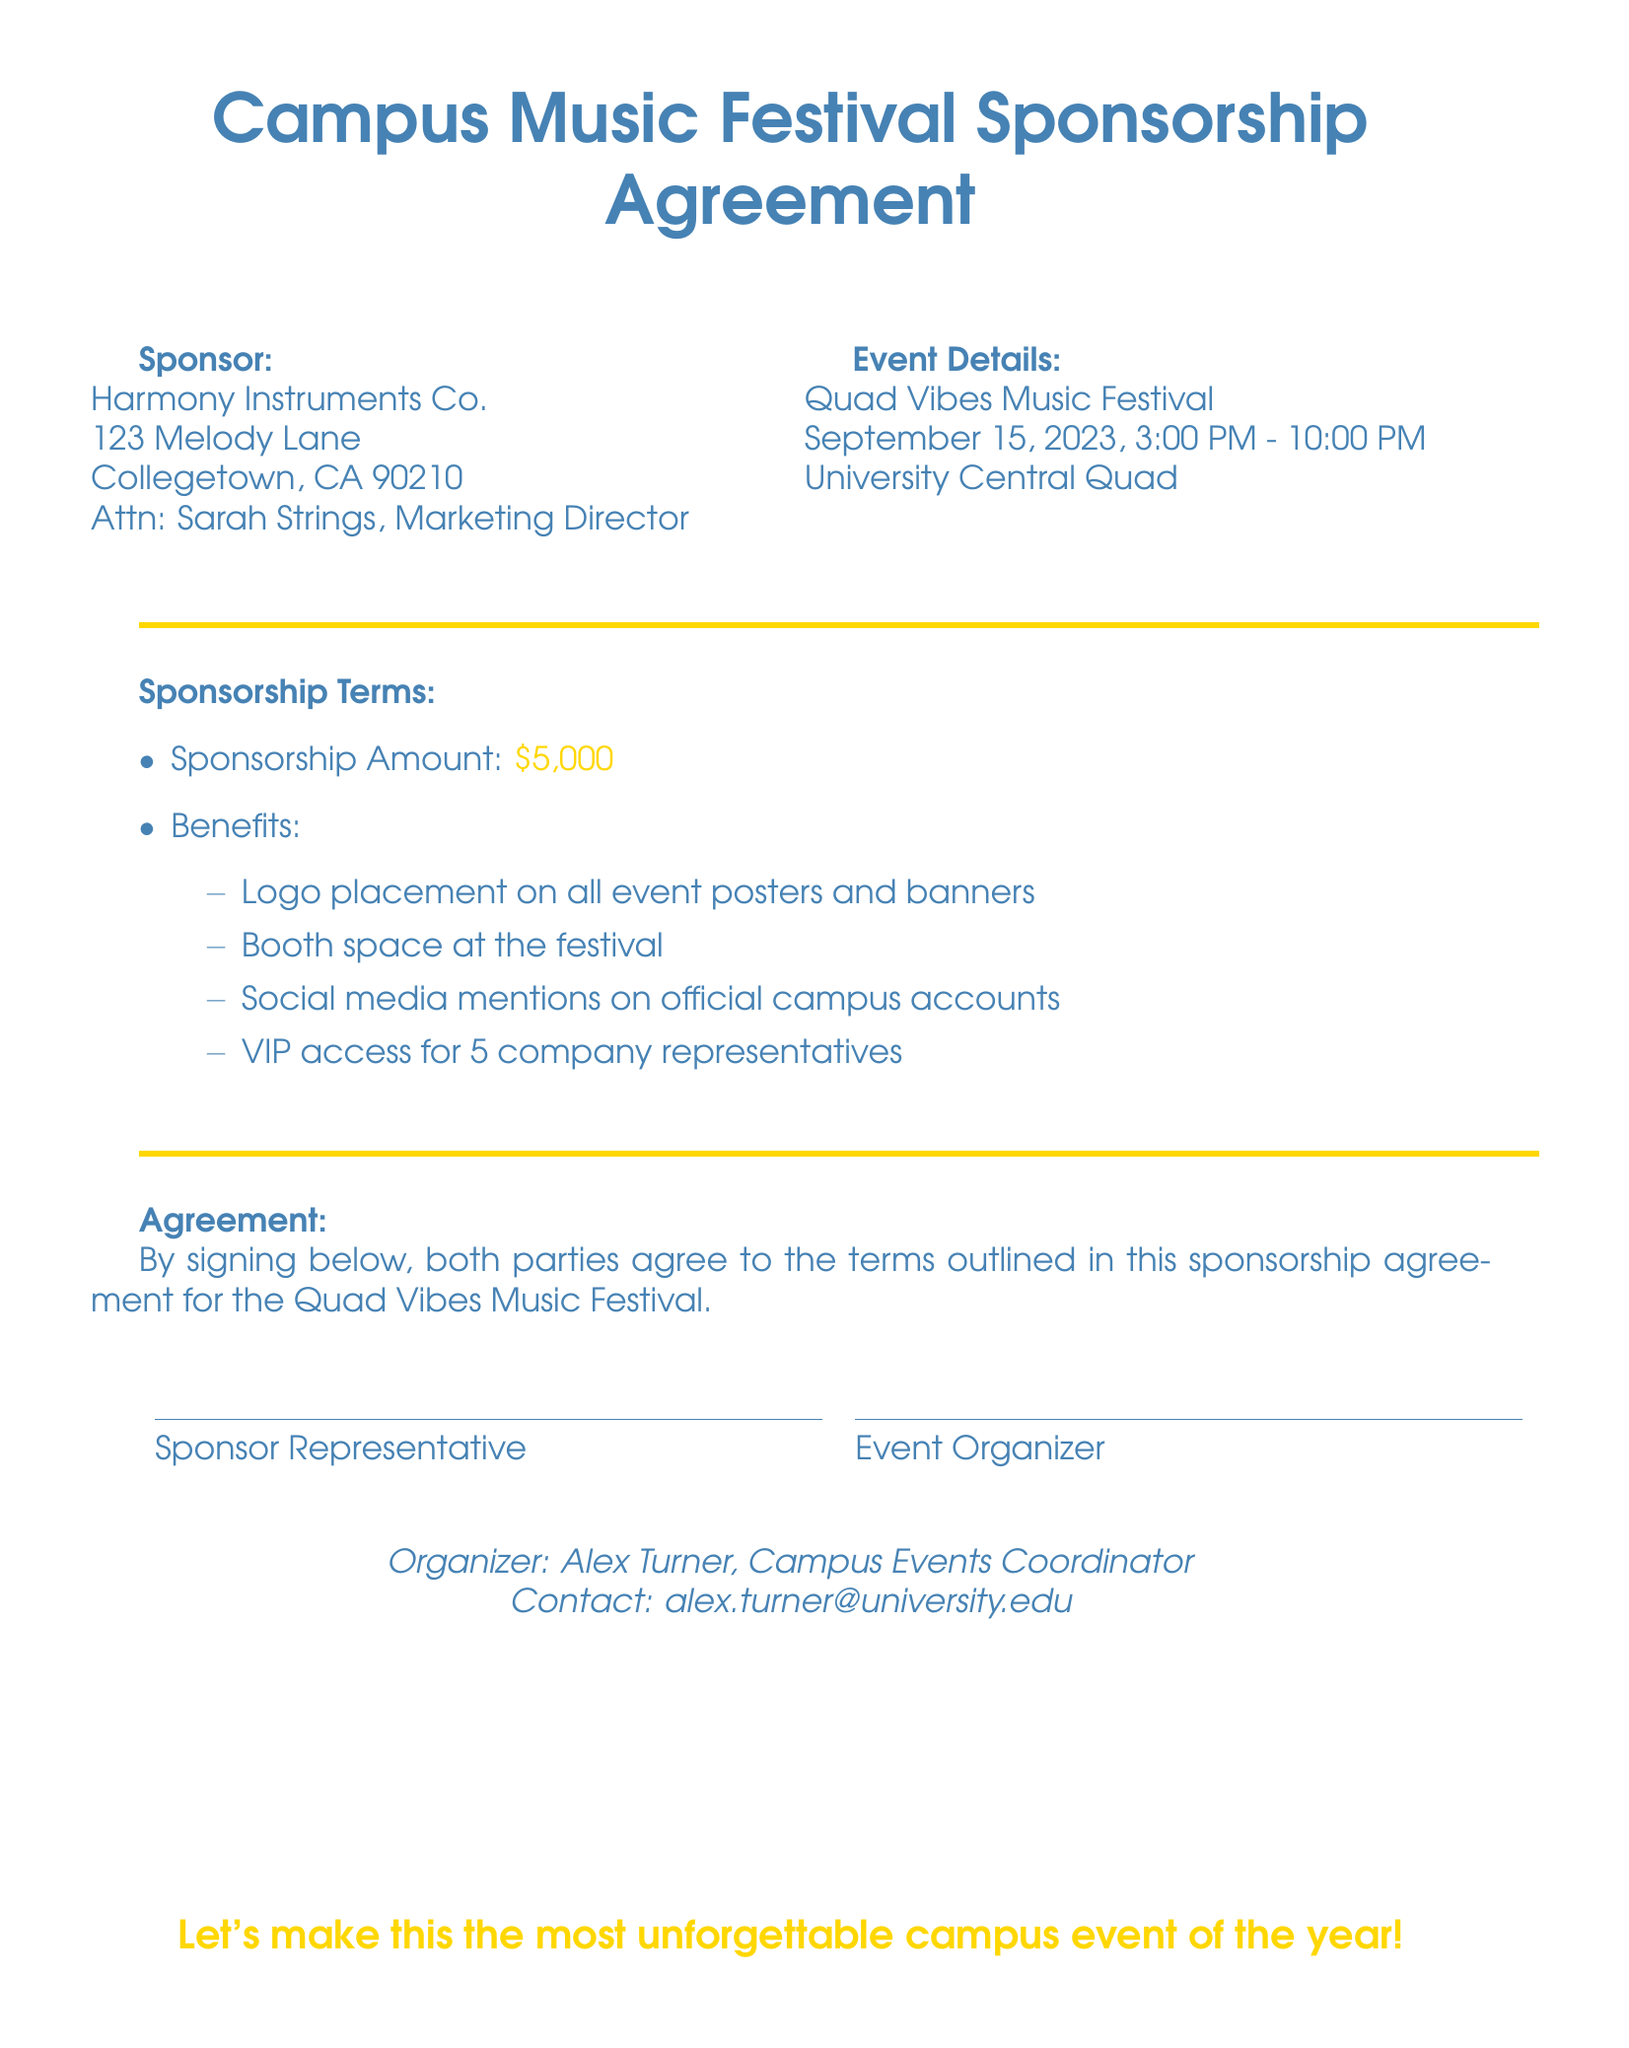What is the name of the sponsoring company? The name of the sponsoring company is listed in the document under "Sponsor."
Answer: Harmony Instruments Co What is the event date? The event date is specified in the "Event Details" section of the document.
Answer: September 15, 2023 How much is the sponsorship amount? The sponsorship amount is mentioned in the "Sponsorship Terms" section of the document.
Answer: $5,000 Who is the contact person for the event? The contact person is named at the bottom of the document under "Organizer."
Answer: Alex Turner What benefits does the sponsorship include? The benefits are listed in the "Benefits" subsection of the "Sponsorship Terms."
Answer: Logo placement on all event posters and banners, Booth space at the festival, Social media mentions on official campus accounts, VIP access for 5 company representatives How many hours will the festival last? The duration of the festival is determined by the start and end times listed in the "Event Details."
Answer: 7 hours What is the location of the music festival? The festival's location is provided in the "Event Details" section of the document.
Answer: University Central Quad Who is the Marketing Director of Harmony Instruments Co.? The Marketing Director’s name appears in the "Sponsor" section of the document.
Answer: Sarah Strings What color theme is used in the document for the festival? The color used for the festival theme is indicated by the defined colors in the document.
Answer: Festival blue 